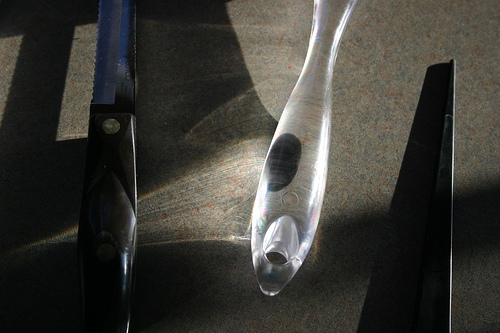<image>
Can you confirm if the knife is behind the handle? No. The knife is not behind the handle. From this viewpoint, the knife appears to be positioned elsewhere in the scene. 